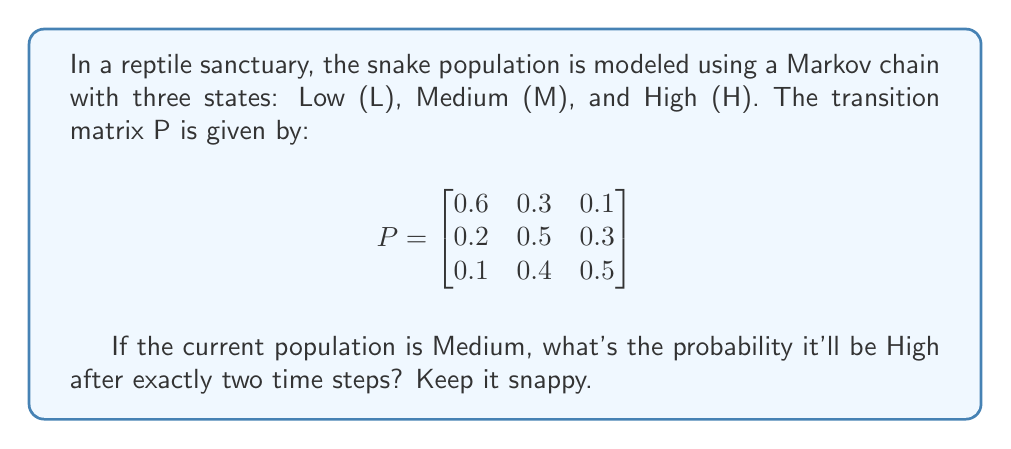Show me your answer to this math problem. Let's bite into this problem with minimal fuss:

1) We start in state M (Medium).

2) We need to find the probability of going from M to H in two steps.

3) This can be calculated using the Chapman-Kolmogorov equation:

   $$P_{MH}^{(2)} = \sum_{k} P_{Mk}^{(1)} P_{kH}^{(1)}$$

   where k represents all possible intermediate states (L, M, H).

4) Let's break it down:
   
   $$P_{MH}^{(2)} = P_{ML}^{(1)} P_{LH}^{(1)} + P_{MM}^{(1)} P_{MH}^{(1)} + P_{MH}^{(1)} P_{HH}^{(1)}$$

5) Plugging in the values from the transition matrix:

   $$P_{MH}^{(2)} = (0.2 \times 0.1) + (0.5 \times 0.3) + (0.3 \times 0.5)$$

6) Calculate:
   
   $$P_{MH}^{(2)} = 0.02 + 0.15 + 0.15 = 0.32$$

That's all there is to it.
Answer: 0.32 